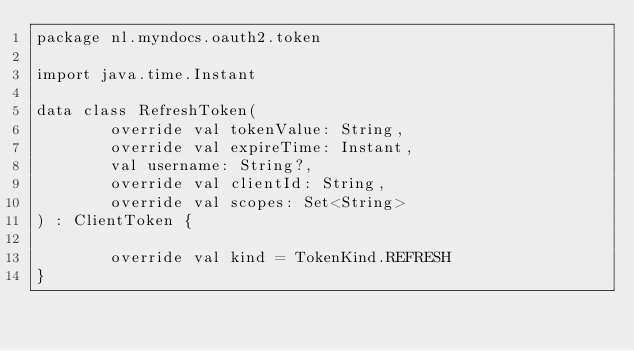Convert code to text. <code><loc_0><loc_0><loc_500><loc_500><_Kotlin_>package nl.myndocs.oauth2.token

import java.time.Instant

data class RefreshToken(
        override val tokenValue: String,
        override val expireTime: Instant,
        val username: String?,
        override val clientId: String,
        override val scopes: Set<String>
) : ClientToken {

        override val kind = TokenKind.REFRESH
}</code> 